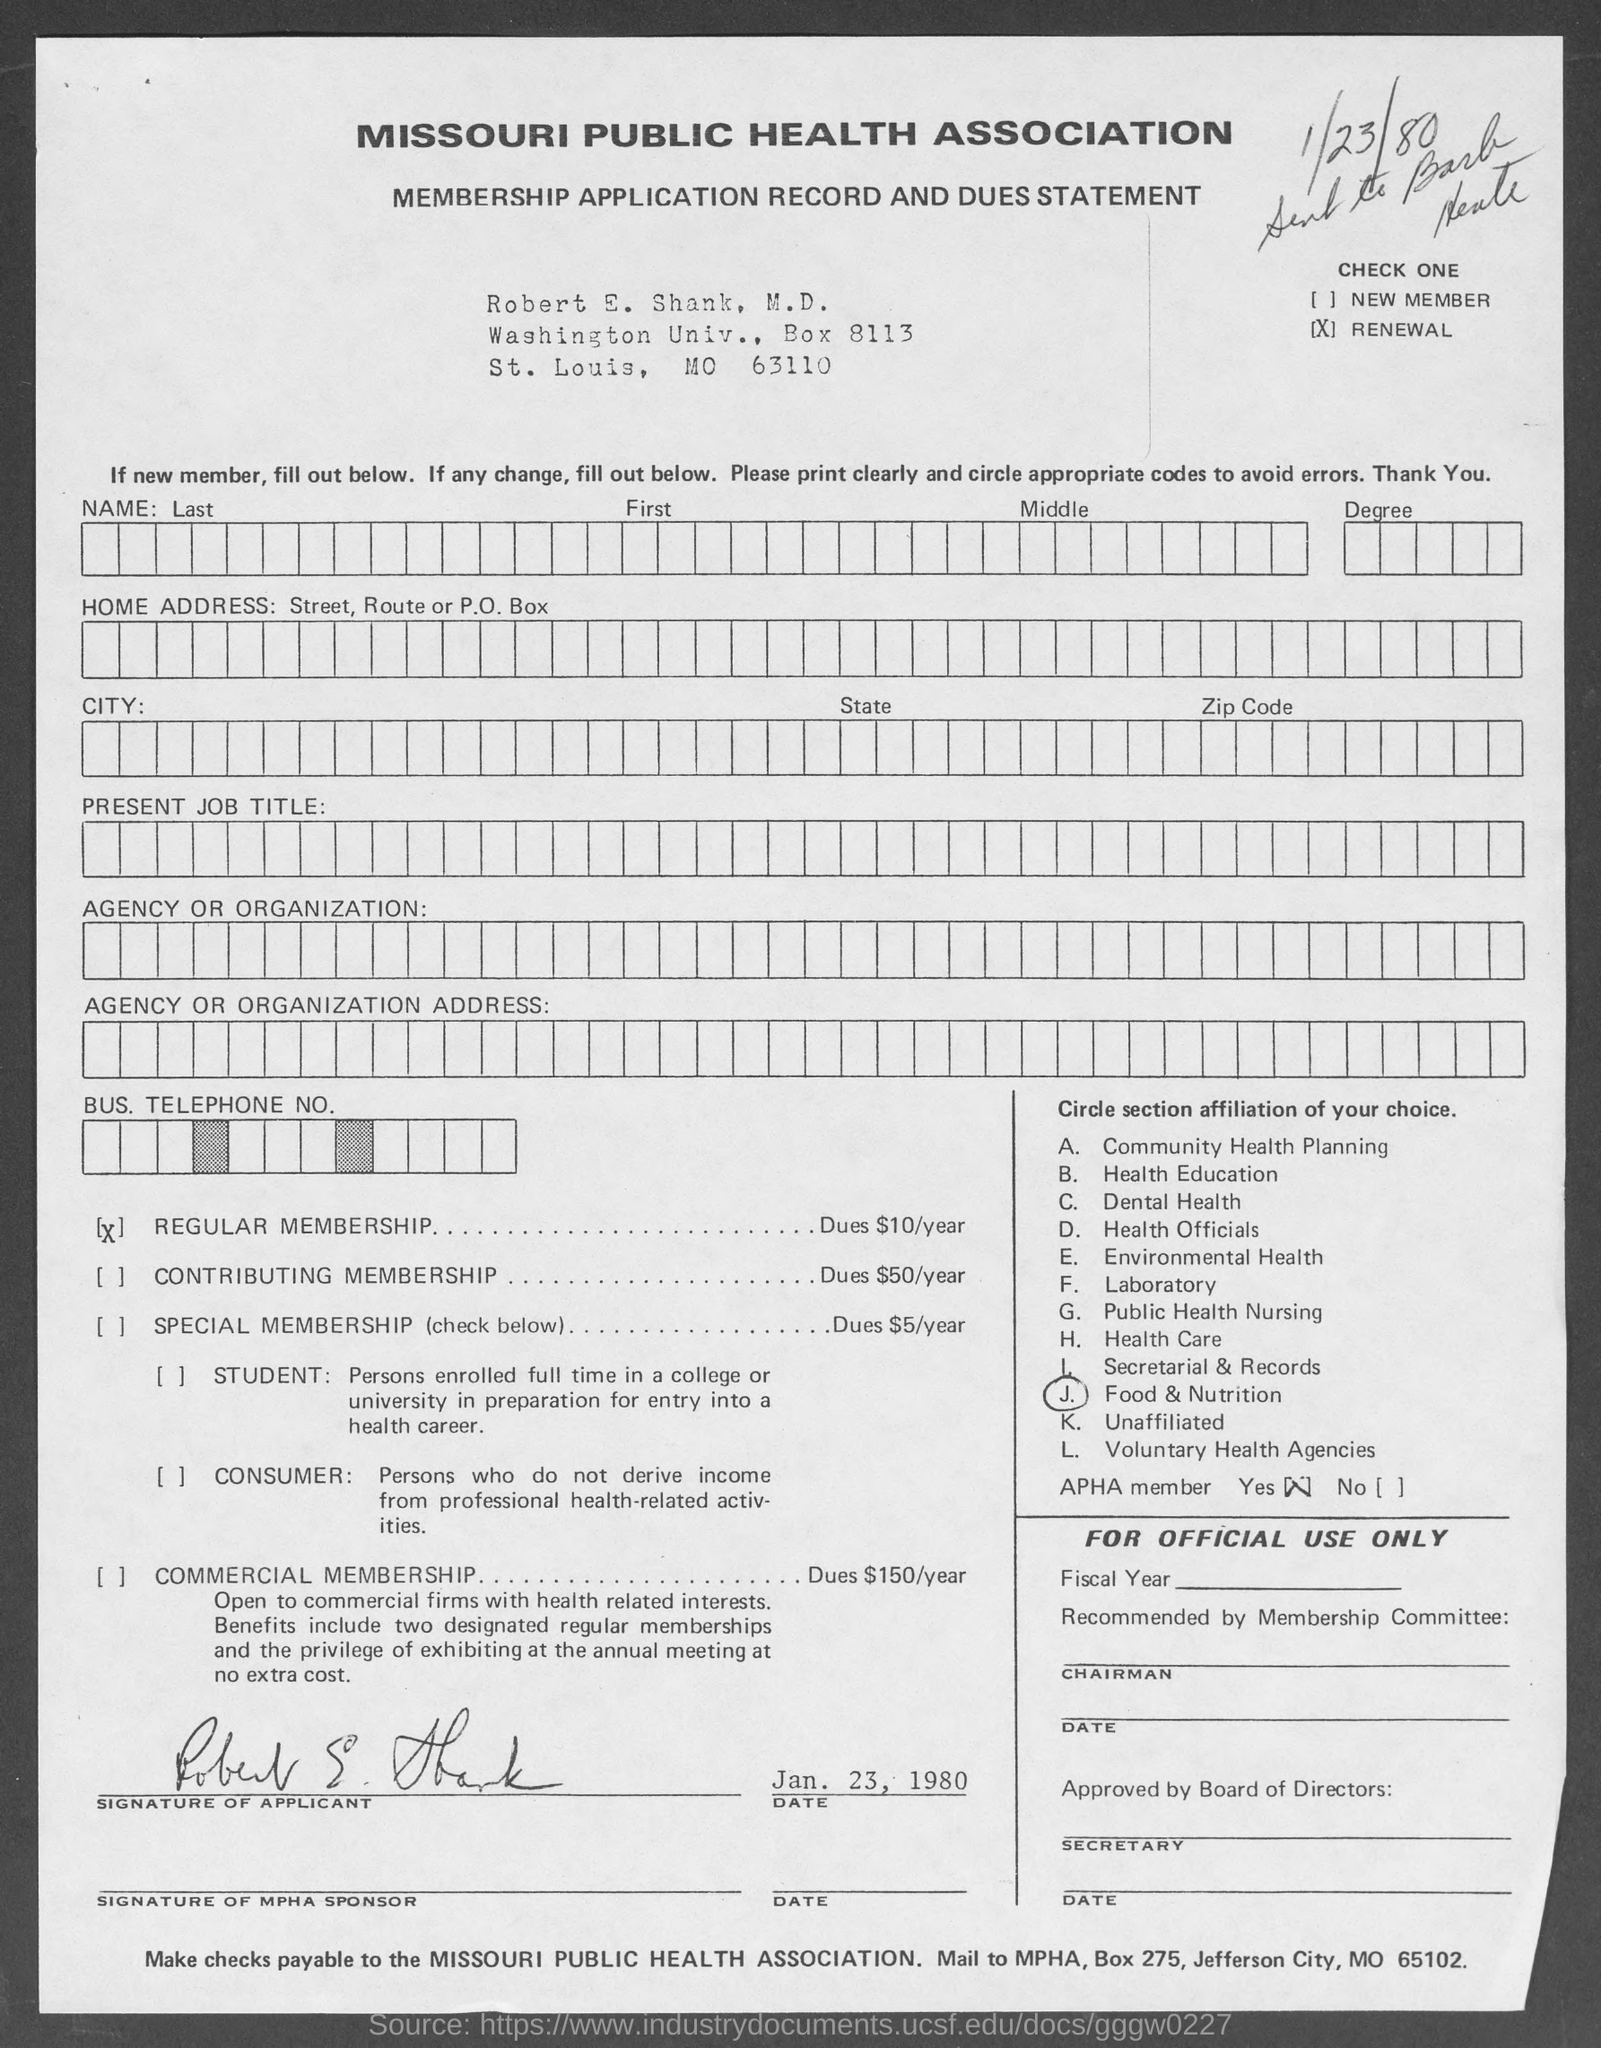What is the name of the organisation?
Your response must be concise. Missouri Public Health Association. What is the given document about?
Provide a short and direct response. Membership Application Record and Dues statement. 